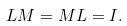Convert formula to latex. <formula><loc_0><loc_0><loc_500><loc_500>L M = M L = I .</formula> 